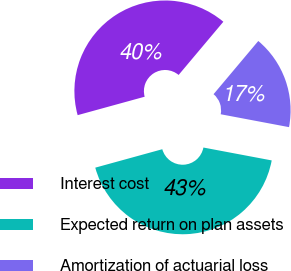Convert chart. <chart><loc_0><loc_0><loc_500><loc_500><pie_chart><fcel>Interest cost<fcel>Expected return on plan assets<fcel>Amortization of actuarial loss<nl><fcel>40.4%<fcel>42.76%<fcel>16.84%<nl></chart> 